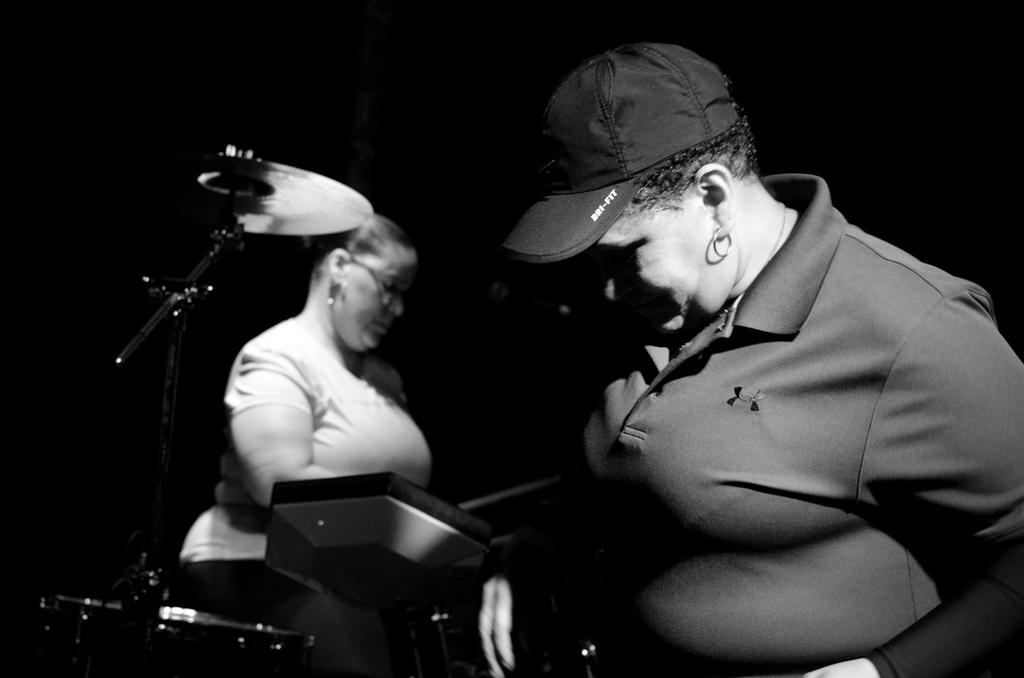What is the color scheme of the image? The image is black and white. How many people are in the image? There are two people standing in the image. What else can be seen in the image besides the people? There are musical instruments in the image. What is the background of the image like? The background of the image is dark. What type of plastic object is being used by the people in the image? There is no plastic object visible in the image; it is a black and white image with two people and musical instruments. Can you describe the potato scene in the image? There is no potato scene present in the image; it features two people and musical instruments against a dark background. 